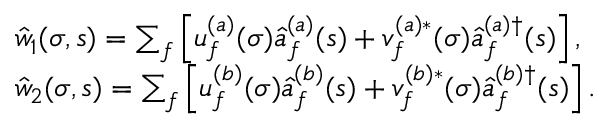<formula> <loc_0><loc_0><loc_500><loc_500>\begin{array} { r l } & { { \hat { w } } _ { 1 } ( \sigma , s ) = \sum _ { f } \left [ u _ { f } ^ { ( a ) } ( \sigma ) \hat { a } _ { f } ^ { ( a ) } ( s ) + v _ { f } ^ { ( a ) \ast } ( \sigma ) \hat { a } _ { f } ^ { ( a ) \dagger } ( s ) \right ] , } \\ & { { \hat { w } } _ { 2 } ( \sigma , s ) = \sum _ { f } \left [ u _ { f } ^ { ( b ) } ( \sigma ) \hat { a } _ { f } ^ { ( b ) } ( s ) + v _ { f } ^ { ( b ) \ast } ( \sigma ) \hat { a } _ { f } ^ { ( b ) \dagger } ( s ) \right ] . } \end{array}</formula> 